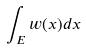<formula> <loc_0><loc_0><loc_500><loc_500>\int _ { E } w ( x ) d x</formula> 